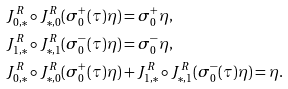<formula> <loc_0><loc_0><loc_500><loc_500>& J ^ { R } _ { 0 , * } \circ J ^ { R } _ { * , 0 } ( \sigma ^ { + } _ { 0 } ( \tau ) \eta ) = \sigma ^ { + } _ { 0 } \eta , \\ & J ^ { R } _ { 1 , * } \circ J ^ { R } _ { * , 1 } ( \sigma ^ { - } _ { 0 } ( \tau ) \eta ) = \sigma ^ { - } _ { 0 } \eta , \\ & J ^ { R } _ { 0 , * } \circ J ^ { R } _ { * , 0 } ( \sigma ^ { + } _ { 0 } ( \tau ) \eta ) + J ^ { R } _ { 1 , * } \circ J ^ { R } _ { * , 1 } ( \sigma ^ { - } _ { 0 } ( \tau ) \eta ) = \eta .</formula> 